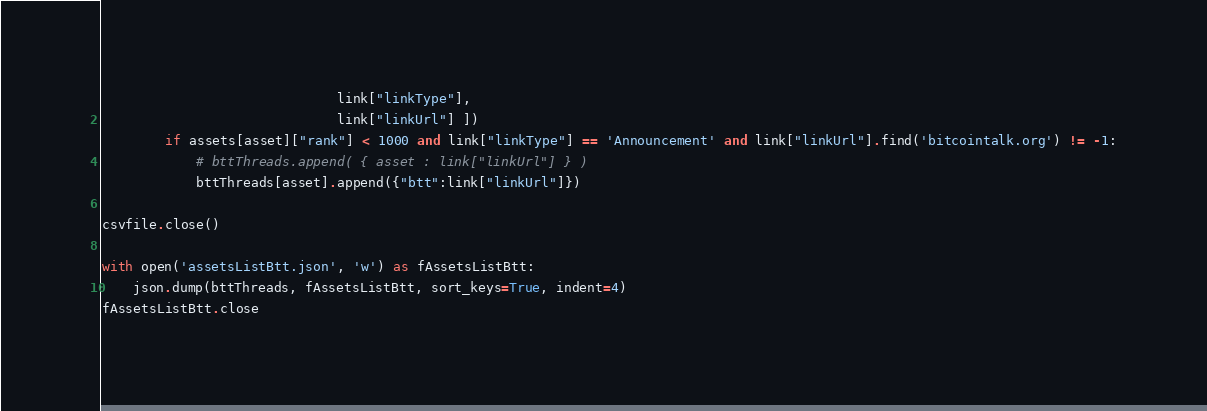Convert code to text. <code><loc_0><loc_0><loc_500><loc_500><_Python_>                              link["linkType"],
                              link["linkUrl"] ])
        if assets[asset]["rank"] < 1000 and link["linkType"] == 'Announcement' and link["linkUrl"].find('bitcointalk.org') != -1:
            # bttThreads.append( { asset : link["linkUrl"] } )
            bttThreads[asset].append({"btt":link["linkUrl"]})
            
csvfile.close()

with open('assetsListBtt.json', 'w') as fAssetsListBtt:
    json.dump(bttThreads, fAssetsListBtt, sort_keys=True, indent=4)
fAssetsListBtt.close</code> 